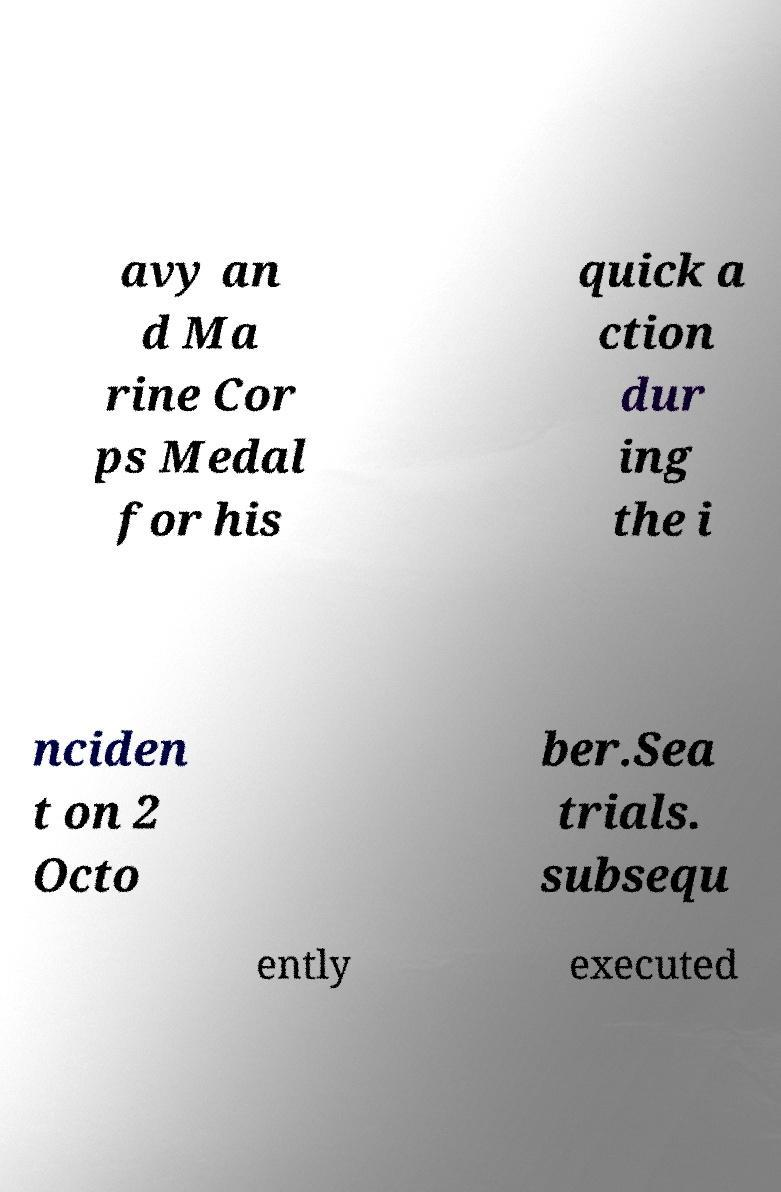Could you extract and type out the text from this image? avy an d Ma rine Cor ps Medal for his quick a ction dur ing the i nciden t on 2 Octo ber.Sea trials. subsequ ently executed 